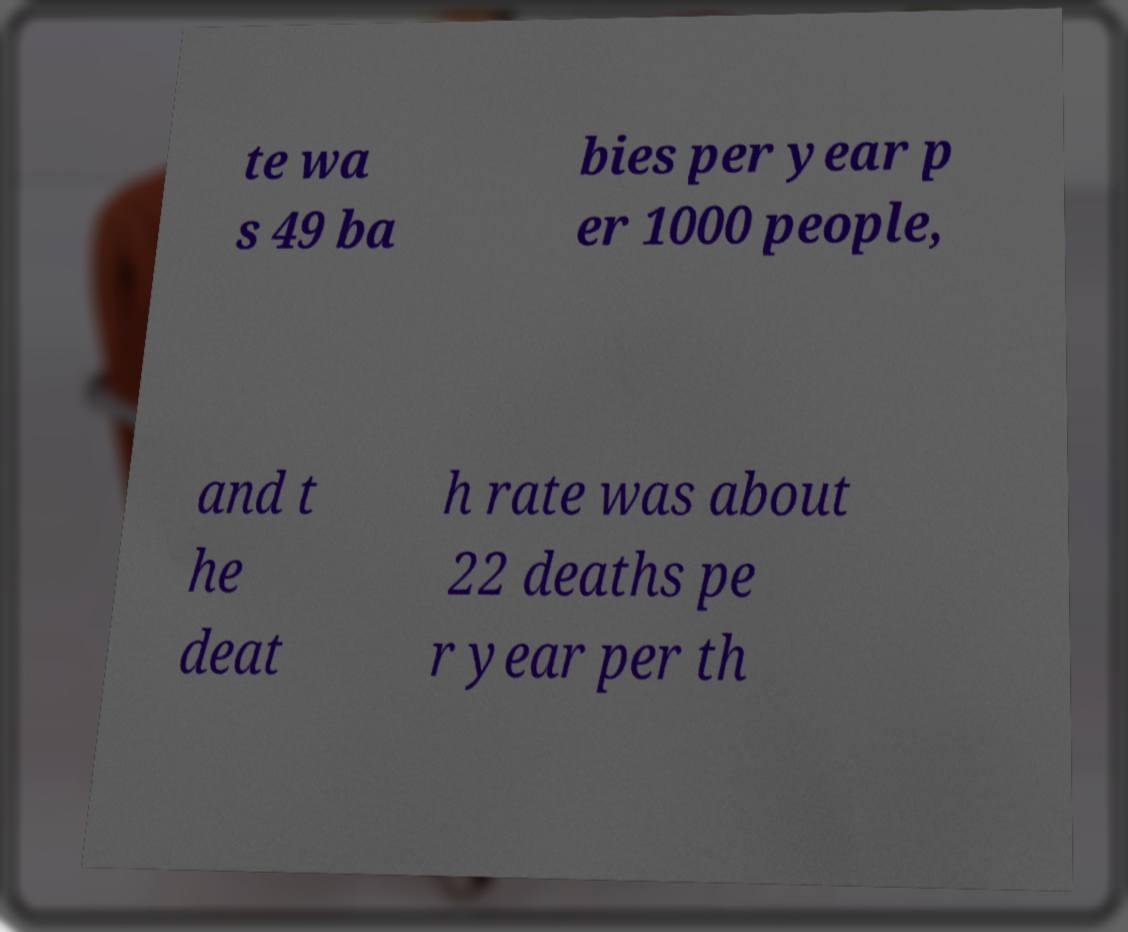Can you read and provide the text displayed in the image?This photo seems to have some interesting text. Can you extract and type it out for me? te wa s 49 ba bies per year p er 1000 people, and t he deat h rate was about 22 deaths pe r year per th 